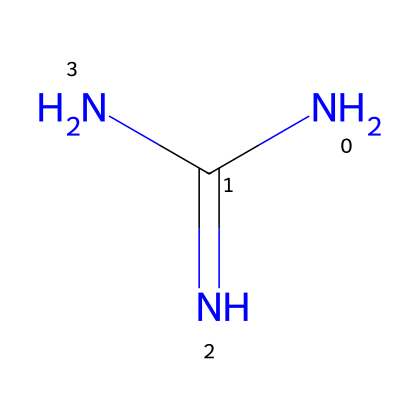What is the total number of nitrogen atoms in guanidine? In the given SMILES representation, NC(=N)N, we can identify the nitrogen atoms. There are three nitrogen symbols (N) present in the structure, indicating a total of three nitrogen atoms.
Answer: three What type of functional groups are present in guanidine? Analyzing the SMILES, we see that there is a carbon atom (C) double-bonded to a nitrogen atom (N) and single-bonded to two other nitrogen atoms. This indicates that guanidine has amine functional groups, specifically primary amines and a amidine structure.
Answer: amine How many double bonds are in guanidine? In the provided SMILES NC(=N)N, there is one double bond, which is represented by the "=" sign between the carbon and one of the nitrogen atoms. Therefore, there is only one double bond in the structure.
Answer: one What is the oxidation state of carbon in guanidine? Looking at the carbon atom in the structure NC(=N)N, we observe that carbon is bonded to one nitrogen with a double bond and two others with single bonds. This results in carbon having four bonds total, typically the oxidation state of carbon in this case is considered to be zero.
Answer: zero Is guanidine a strong base? Guanidine is known for its ability to accept protons due to the presence of multiple nitrogen atoms that can share their lone pairs. This makes guanidine a strong base as it readily dissociates in solution to attract protons.
Answer: yes What type of molecule is guanidine classified as? Based on its structure, with amine groups and the ability to act as a proton acceptor, guanidine is classified as a superbase. This classification stems from its high proton affinity and basicity in comparison to traditional bases.
Answer: superbase 